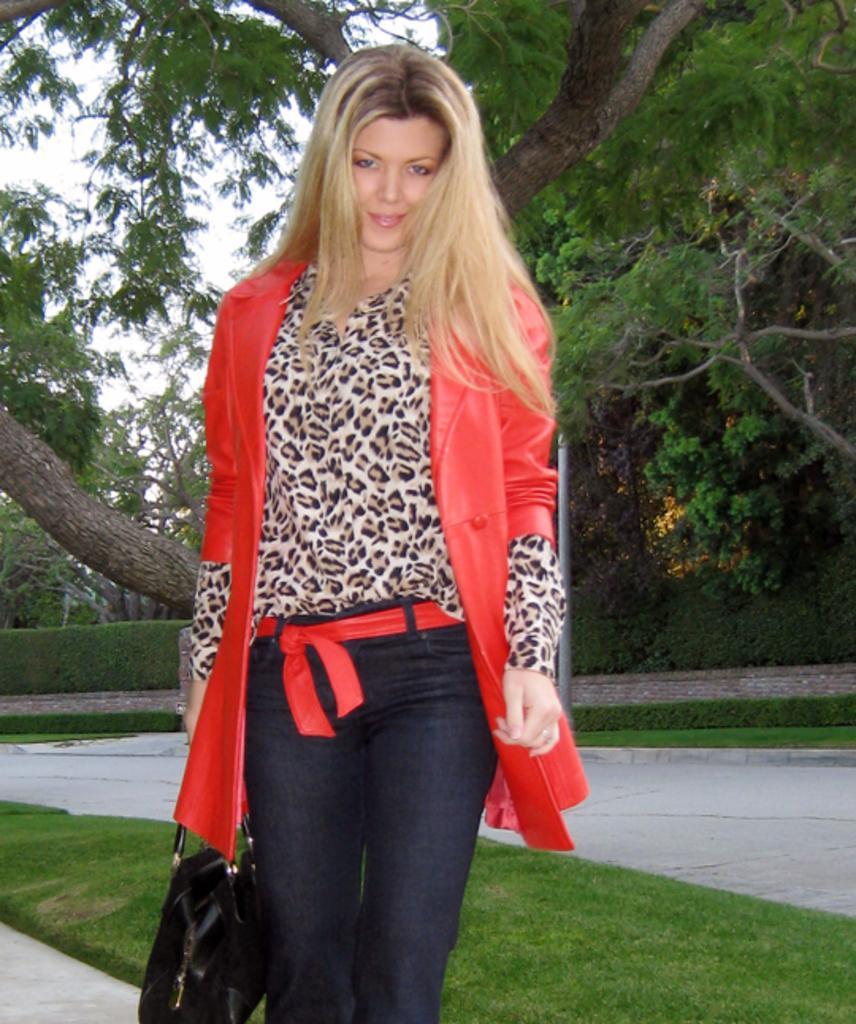Describe this image in one or two sentences. In the middle of the image there is a lady with red jacket, blue jeans and a red belt is standing and holding the bag in her hand. Behind her there is a grass on the ground. Behind the grass there is a road. In the background there are plants and also there are trees. 